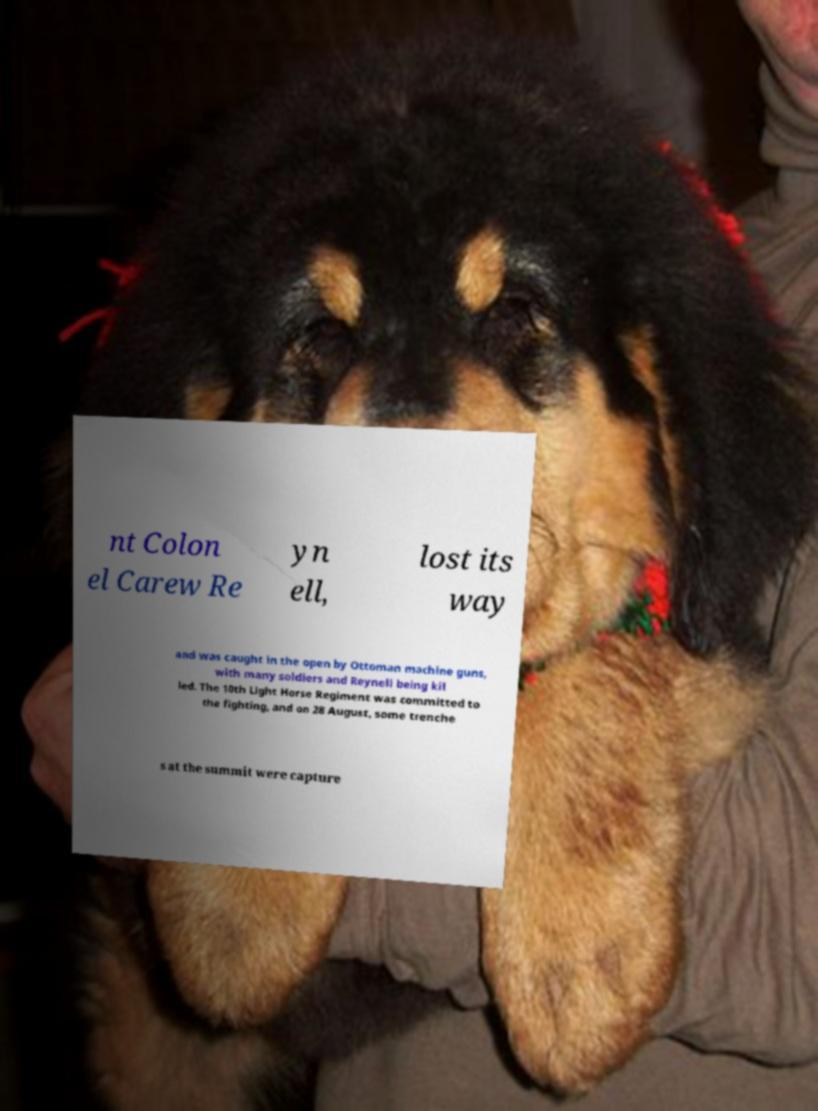What messages or text are displayed in this image? I need them in a readable, typed format. nt Colon el Carew Re yn ell, lost its way and was caught in the open by Ottoman machine guns, with many soldiers and Reynell being kil led. The 10th Light Horse Regiment was committed to the fighting, and on 28 August, some trenche s at the summit were capture 